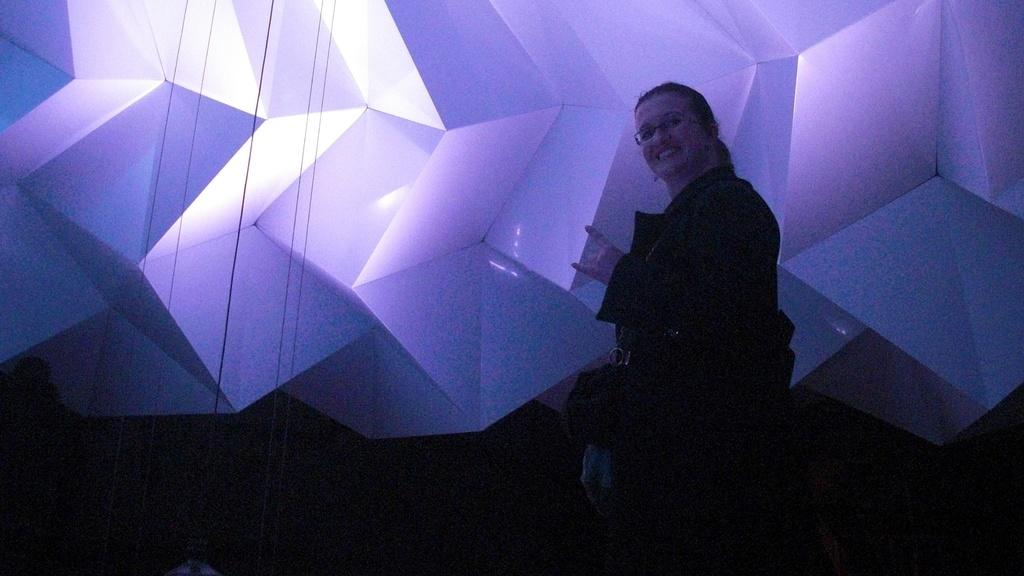Who is the main subject in the image? There is a woman standing in the front of the image. What is the woman's expression in the image? The woman is smiling in the image. What can be seen in the background of the image? There are objects in the background of the image that are white in color, and there are ropes in the background of the image that are black in color. What type of tin can be seen in the image? There is no tin present in the image. What color is the ink used for the woman's smile in the image? The image is a photograph, so there is no ink used for the woman's smile. 